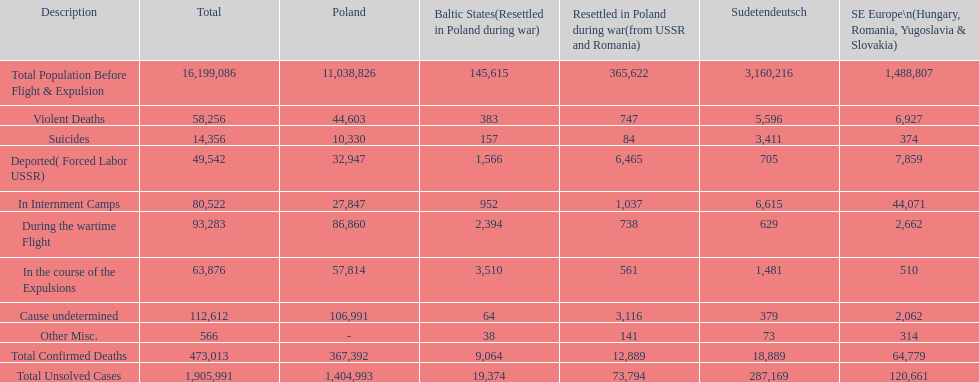How many reasons led to over 50,000 verified fatalities? 5. 